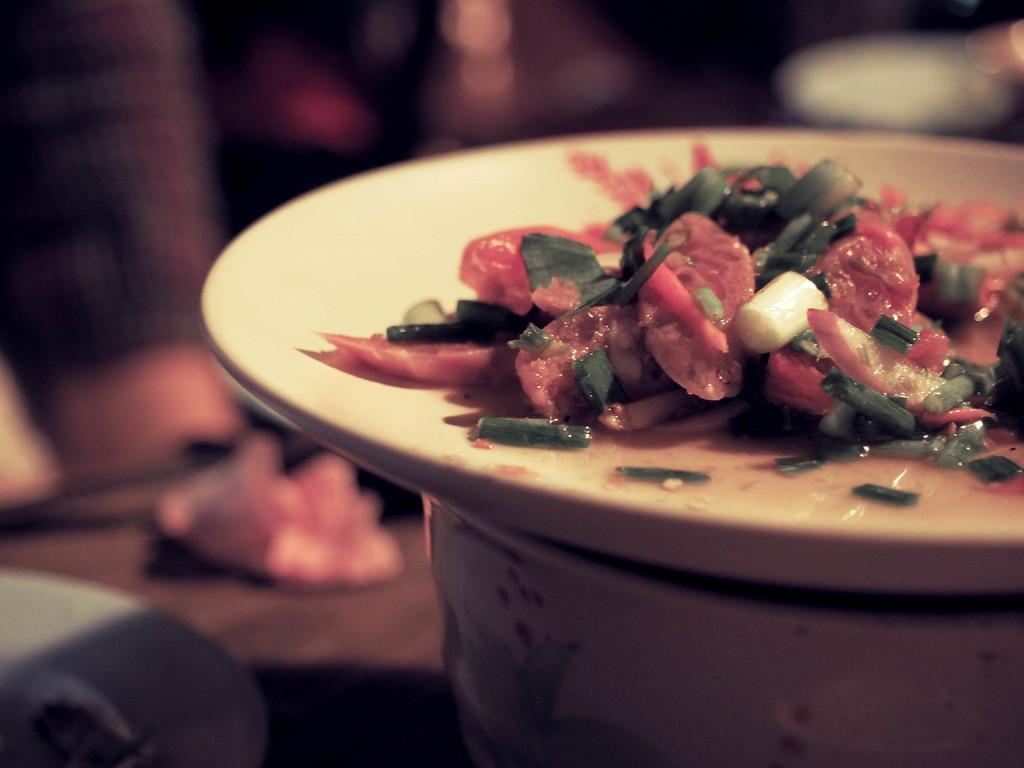In one or two sentences, can you explain what this image depicts? In this image we can see a plate with food item. In the background it is blur. And the plate is on some other vessel. 